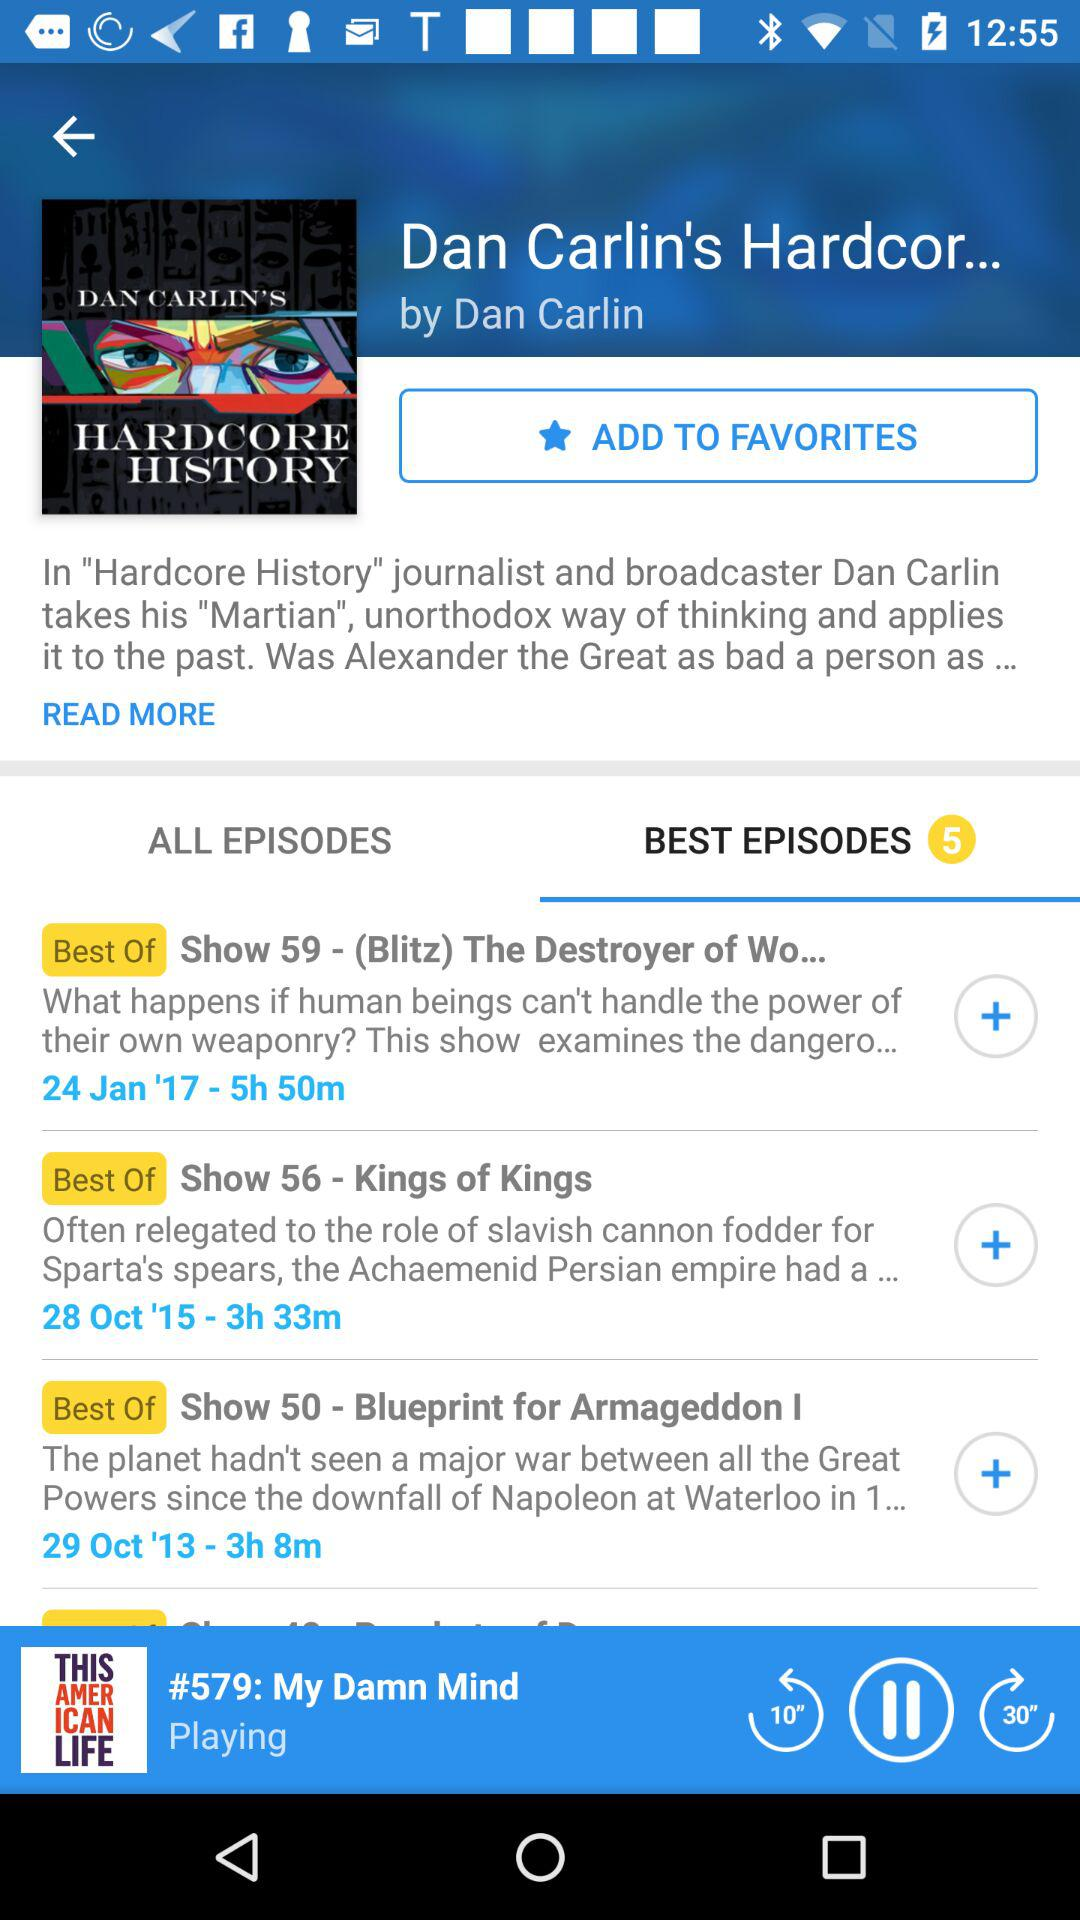How long is the Kings of Kings show? The duration of the Kings of Kings show is 3 hours and 33 minutes. 